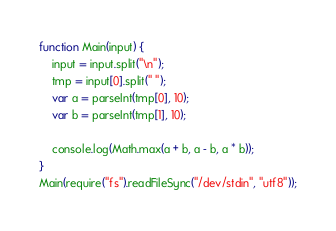<code> <loc_0><loc_0><loc_500><loc_500><_JavaScript_>function Main(input) {
    input = input.split("\n");
  	tmp = input[0].split(" ");
    var a = parseInt(tmp[0], 10);
    var b = parseInt(tmp[1], 10);

	console.log(Math.max(a + b, a - b, a * b));
}
Main(require("fs").readFileSync("/dev/stdin", "utf8"));</code> 